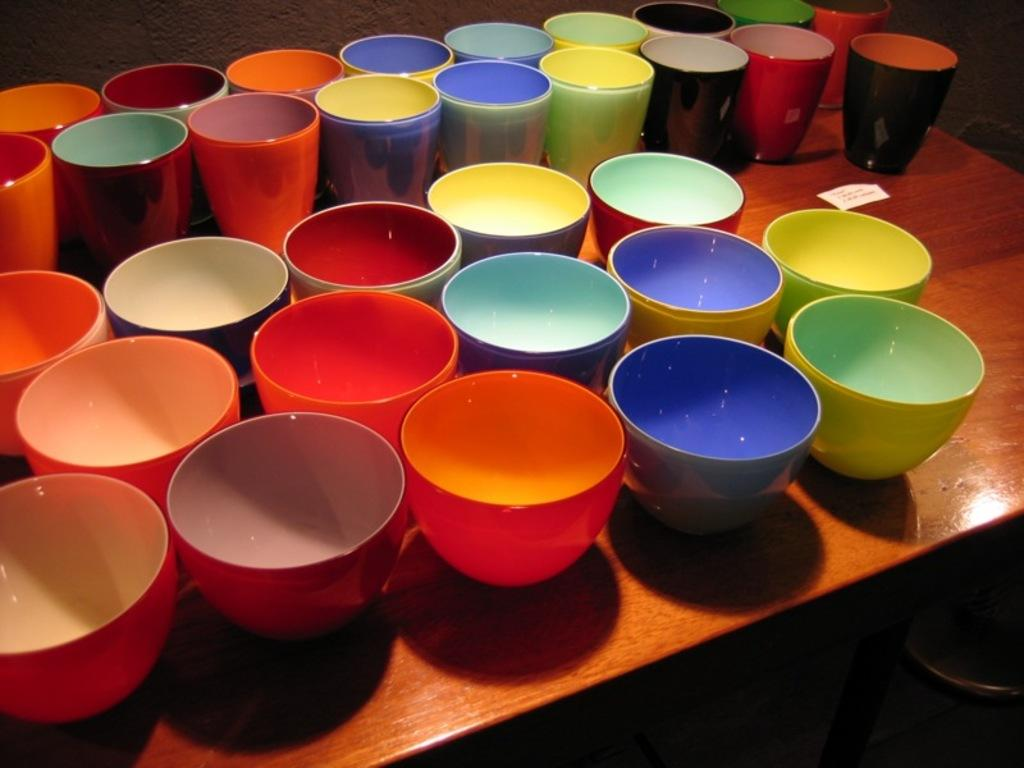What is the main object in the center of the image? There is a table in the center of the image. What items are placed on the table? There are many cups and mugs on the table. What type of cave can be seen in the background of the image? There is no cave present in the image; it only features a table with cups and mugs. 